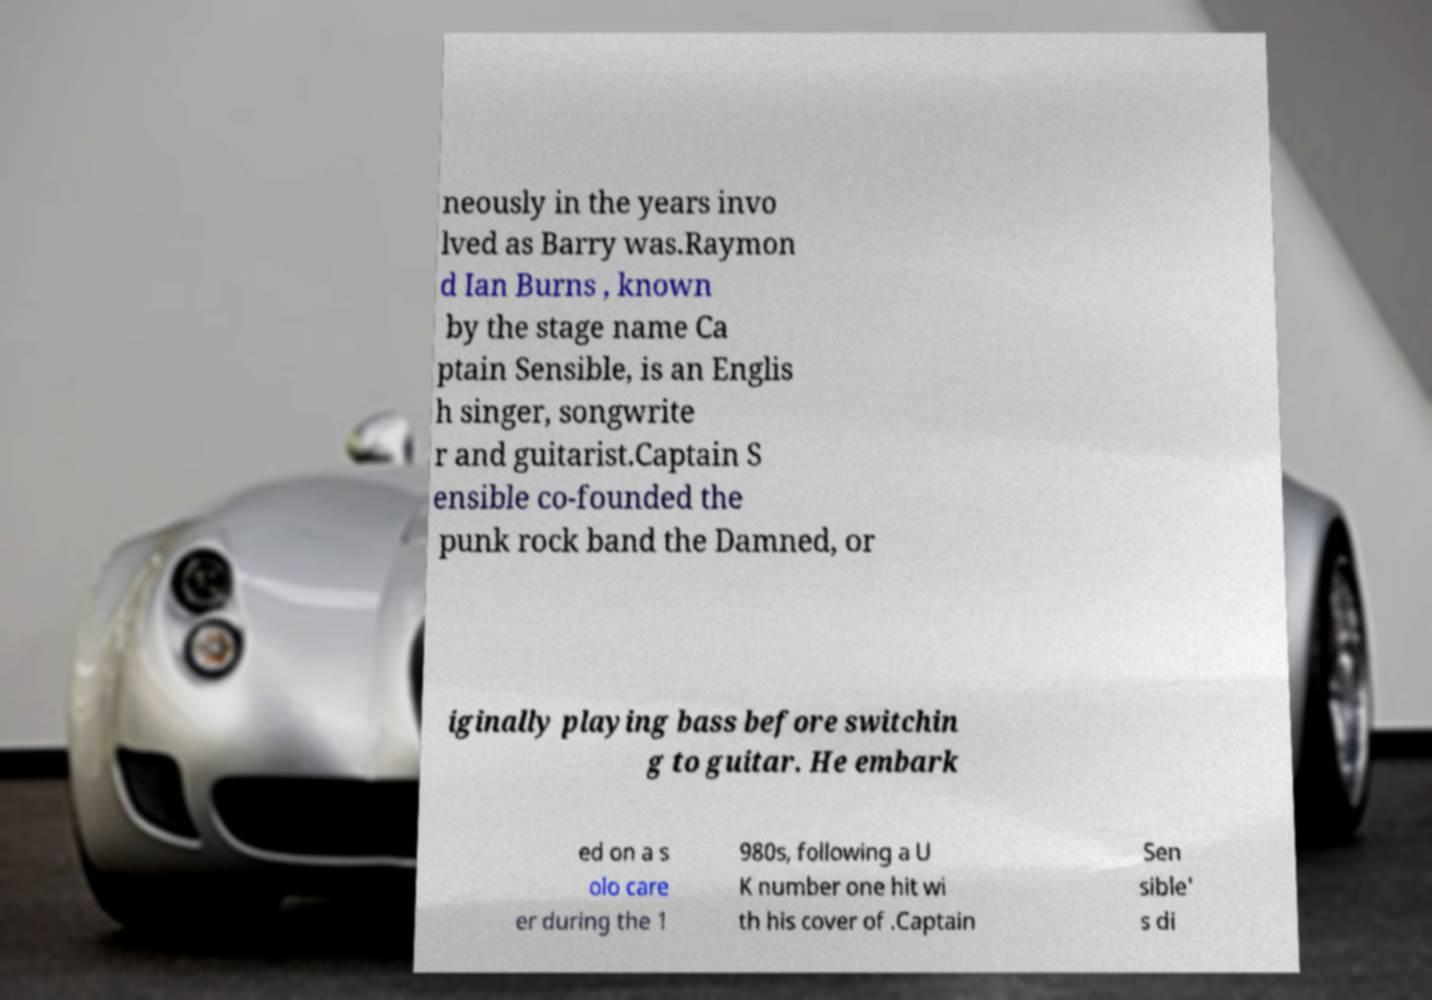Can you read and provide the text displayed in the image?This photo seems to have some interesting text. Can you extract and type it out for me? neously in the years invo lved as Barry was.Raymon d Ian Burns , known by the stage name Ca ptain Sensible, is an Englis h singer, songwrite r and guitarist.Captain S ensible co-founded the punk rock band the Damned, or iginally playing bass before switchin g to guitar. He embark ed on a s olo care er during the 1 980s, following a U K number one hit wi th his cover of .Captain Sen sible' s di 